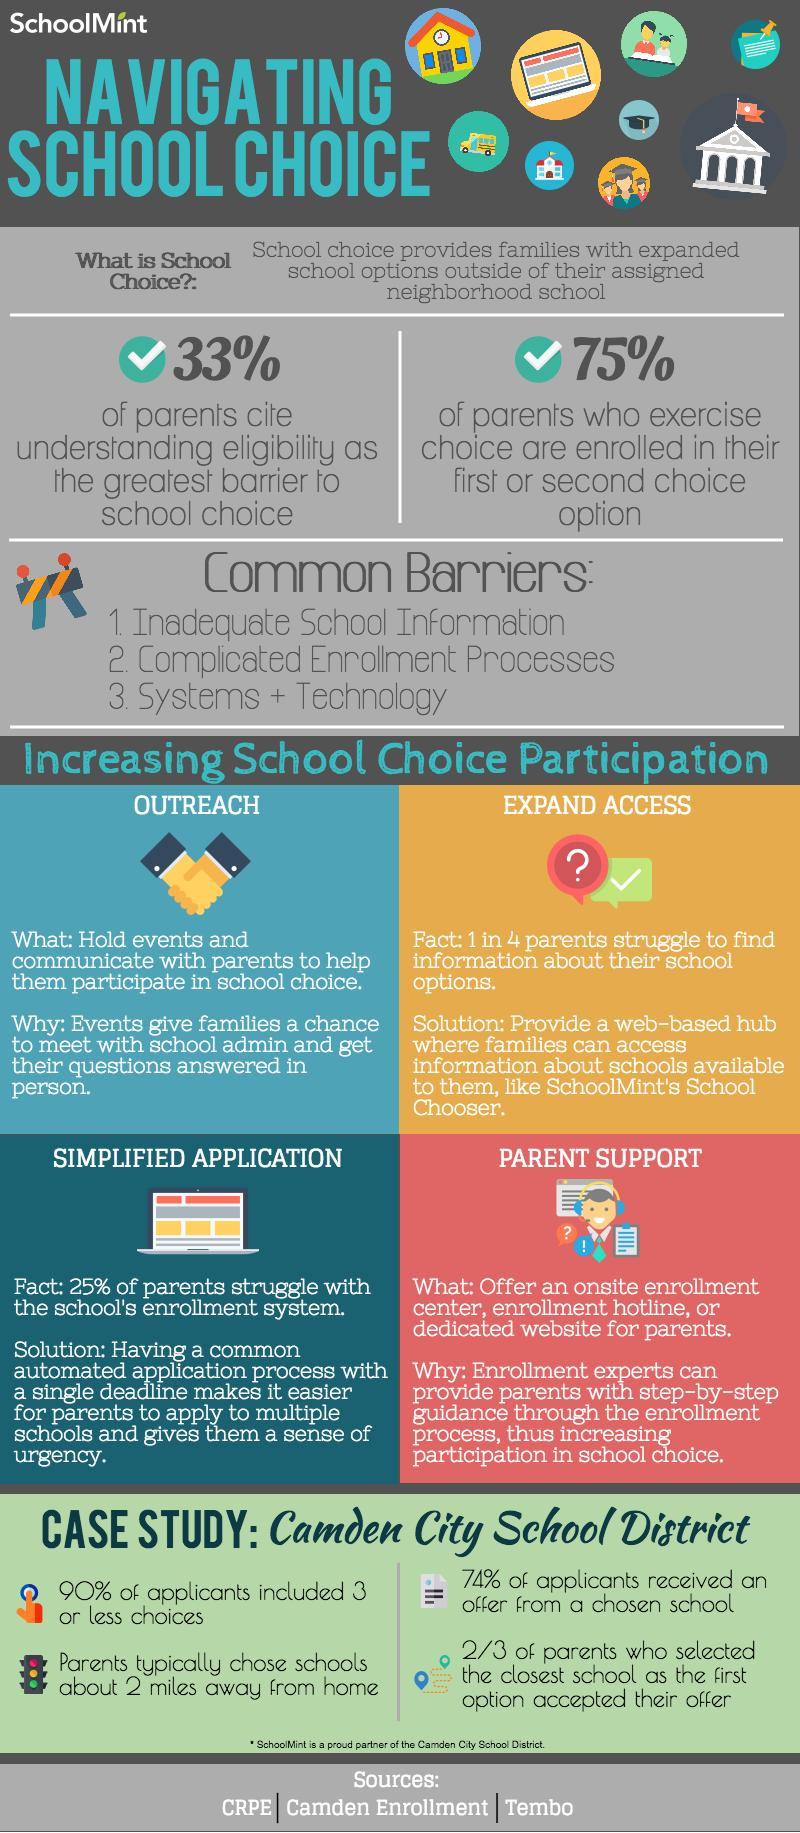Indicate a few pertinent items in this graphic. Approximately 24% of applicants did not receive an offer from the chosen school. According to the survey, a significant percentage of parents of parents do not cite understanding eligibility as the barrier to school choice, with 67% stating otherwise. About 10% of applicants choose to list more than three schools in their options. In the options given, 25% of parents do not choose either the first or second choice of schools. 